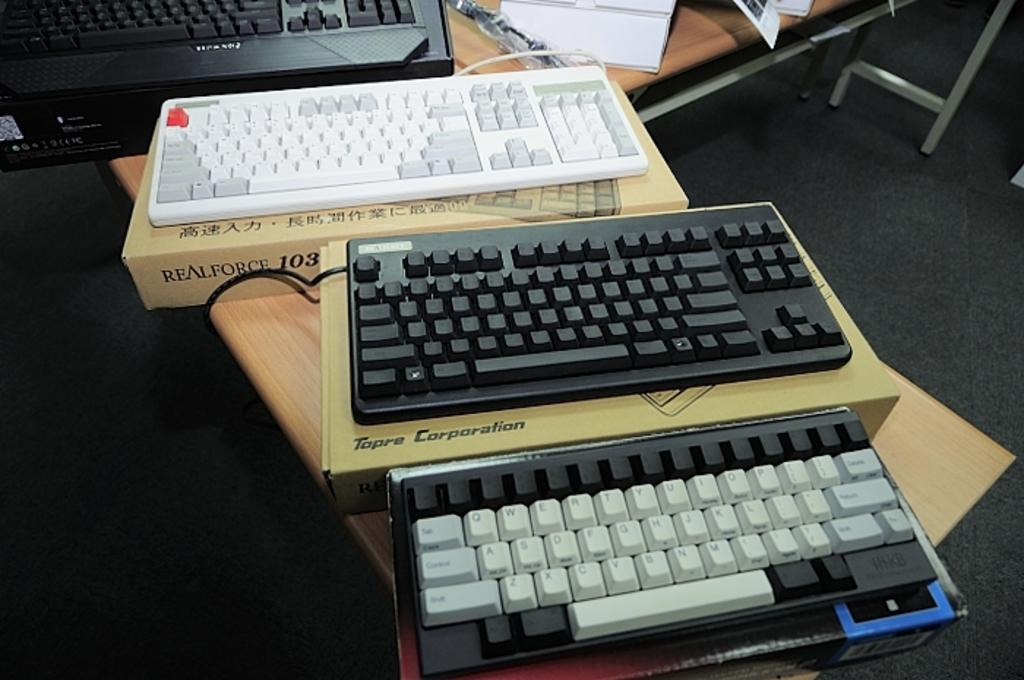Provide a one-sentence caption for the provided image. A Topre Corporation keyboard in between two other keyboards. 